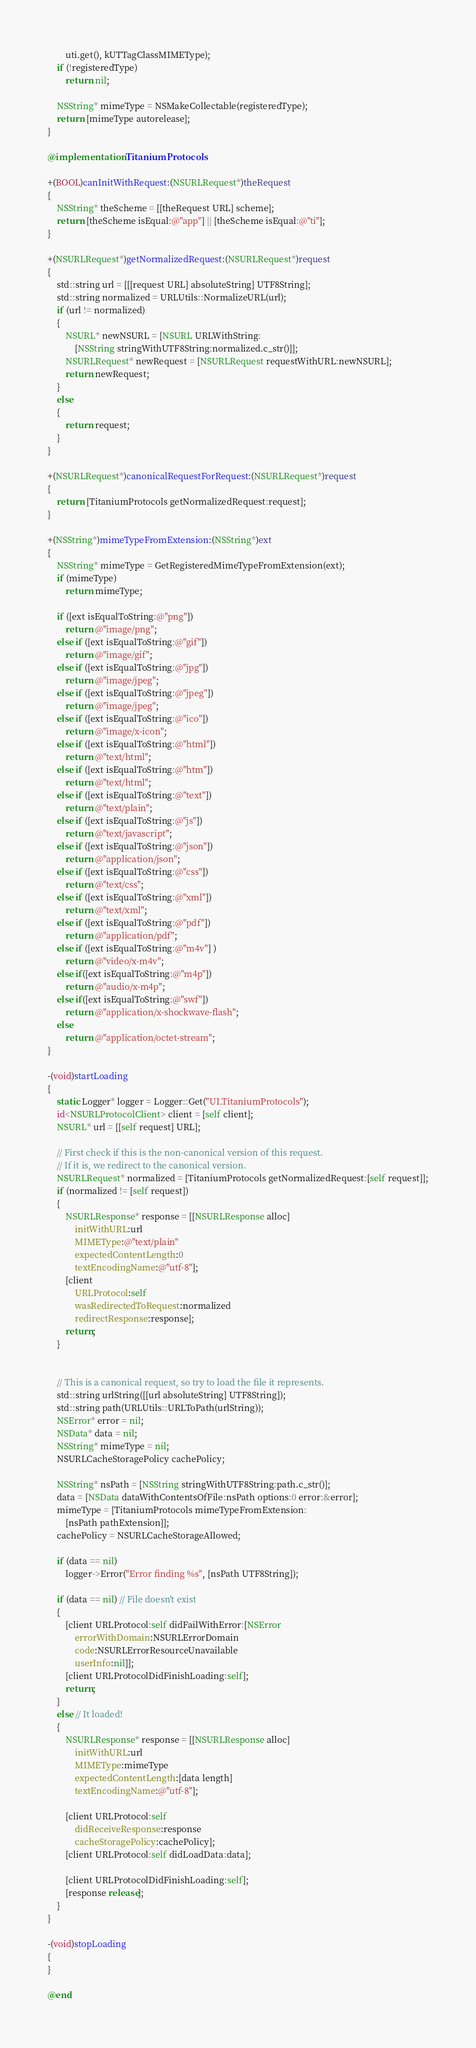<code> <loc_0><loc_0><loc_500><loc_500><_ObjectiveC_>        uti.get(), kUTTagClassMIMEType);
    if (!registeredType)
        return nil;

    NSString* mimeType = NSMakeCollectable(registeredType);
    return [mimeType autorelease];
}

@implementation TitaniumProtocols

+(BOOL)canInitWithRequest:(NSURLRequest*)theRequest 
{
    NSString* theScheme = [[theRequest URL] scheme];
    return [theScheme isEqual:@"app"] || [theScheme isEqual:@"ti"];
}

+(NSURLRequest*)getNormalizedRequest:(NSURLRequest*)request
{
    std::string url = [[[request URL] absoluteString] UTF8String];
    std::string normalized = URLUtils::NormalizeURL(url);
    if (url != normalized)
    {
        NSURL* newNSURL = [NSURL URLWithString:
            [NSString stringWithUTF8String:normalized.c_str()]];
        NSURLRequest* newRequest = [NSURLRequest requestWithURL:newNSURL];
        return newRequest;
    }
    else
    {
        return request;
    }
}

+(NSURLRequest*)canonicalRequestForRequest:(NSURLRequest*)request 
{
    return [TitaniumProtocols getNormalizedRequest:request];
}

+(NSString*)mimeTypeFromExtension:(NSString*)ext
{
    NSString* mimeType = GetRegisteredMimeTypeFromExtension(ext);
    if (mimeType)
        return mimeType;

    if ([ext isEqualToString:@"png"])
        return @"image/png";
    else if ([ext isEqualToString:@"gif"])
        return @"image/gif"; 
    else if ([ext isEqualToString:@"jpg"])
        return @"image/jpeg";
    else if ([ext isEqualToString:@"jpeg"])
        return @"image/jpeg";
    else if ([ext isEqualToString:@"ico"])
        return @"image/x-icon";
    else if ([ext isEqualToString:@"html"])
        return @"text/html";
    else if ([ext isEqualToString:@"htm"])
        return @"text/html";
    else if ([ext isEqualToString:@"text"])
        return @"text/plain";
    else if ([ext isEqualToString:@"js"])
        return @"text/javascript";
    else if ([ext isEqualToString:@"json"])
        return @"application/json";
    else if ([ext isEqualToString:@"css"])
        return @"text/css";
    else if ([ext isEqualToString:@"xml"])
        return @"text/xml";
    else if ([ext isEqualToString:@"pdf"])
        return @"application/pdf";
    else if ([ext isEqualToString:@"m4v"] )
        return @"video/x-m4v";
    else if([ext isEqualToString:@"m4p"])
        return @"audio/x-m4p";
    else if([ext isEqualToString:@"swf"])
        return @"application/x-shockwave-flash";
    else
        return @"application/octet-stream";
}

-(void)startLoading
{
    static Logger* logger = Logger::Get("UI.TitaniumProtocols");
    id<NSURLProtocolClient> client = [self client];
    NSURL* url = [[self request] URL];

    // First check if this is the non-canonical version of this request.
    // If it is, we redirect to the canonical version.
    NSURLRequest* normalized = [TitaniumProtocols getNormalizedRequest:[self request]];
    if (normalized != [self request])
    {
        NSURLResponse* response = [[NSURLResponse alloc]
            initWithURL:url
            MIMEType:@"text/plain"
            expectedContentLength:0
            textEncodingName:@"utf-8"];
        [client 
            URLProtocol:self
            wasRedirectedToRequest:normalized
            redirectResponse:response];
        return;
    }
    

    // This is a canonical request, so try to load the file it represents.
    std::string urlString([[url absoluteString] UTF8String]);
    std::string path(URLUtils::URLToPath(urlString));
    NSError* error = nil;
    NSData* data = nil;
    NSString* mimeType = nil;
    NSURLCacheStoragePolicy cachePolicy;

    NSString* nsPath = [NSString stringWithUTF8String:path.c_str()];
    data = [NSData dataWithContentsOfFile:nsPath options:0 error:&error];
    mimeType = [TitaniumProtocols mimeTypeFromExtension:
        [nsPath pathExtension]];
    cachePolicy = NSURLCacheStorageAllowed;

    if (data == nil)
        logger->Error("Error finding %s", [nsPath UTF8String]);

    if (data == nil) // File doesn't exist
    { 
        [client URLProtocol:self didFailWithError:[NSError
            errorWithDomain:NSURLErrorDomain
            code:NSURLErrorResourceUnavailable
            userInfo:nil]];
        [client URLProtocolDidFinishLoading:self];
        return;
    }
    else // It loaded!
    { 
        NSURLResponse* response = [[NSURLResponse alloc]
            initWithURL:url
            MIMEType:mimeType
            expectedContentLength:[data length]
            textEncodingName:@"utf-8"];

        [client URLProtocol:self
            didReceiveResponse:response
            cacheStoragePolicy:cachePolicy];
        [client URLProtocol:self didLoadData:data];

        [client URLProtocolDidFinishLoading:self];
        [response release];
    }
}

-(void)stopLoading 
{
}

@end
</code> 